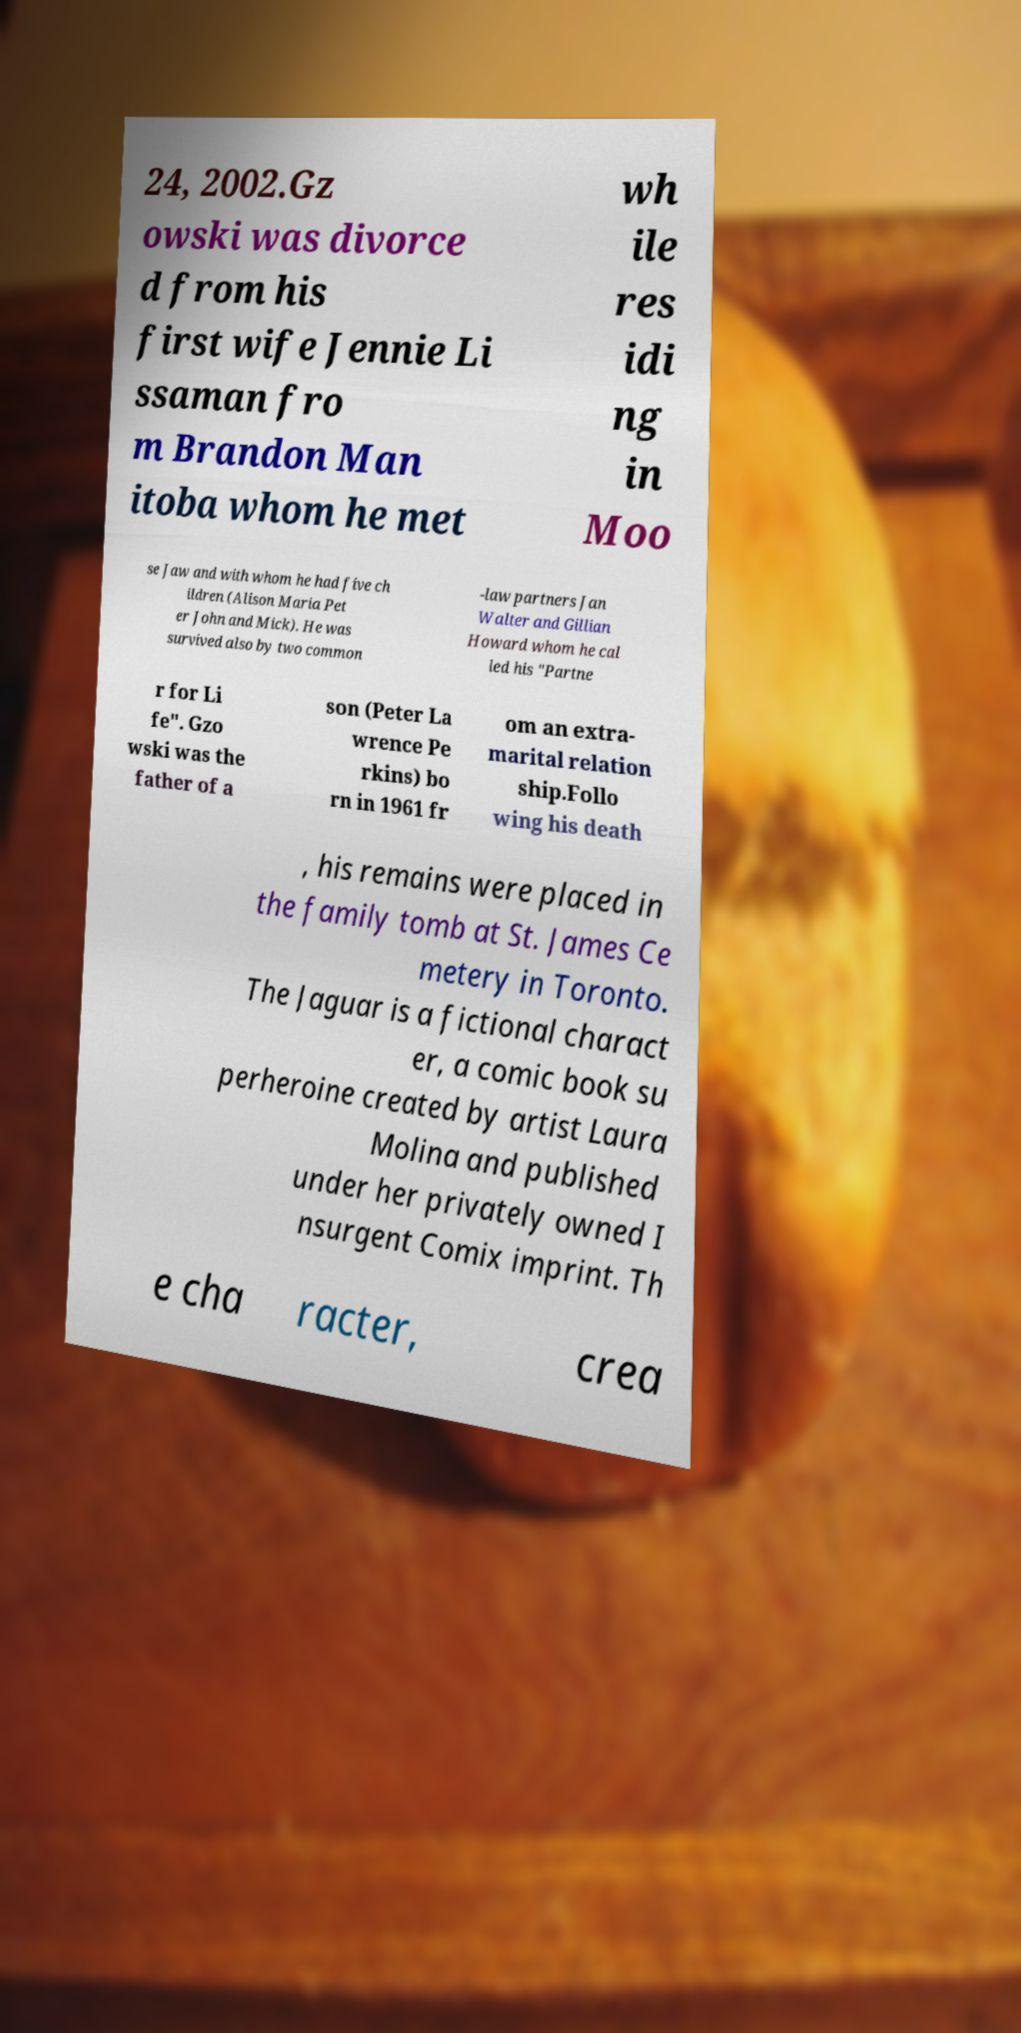What messages or text are displayed in this image? I need them in a readable, typed format. 24, 2002.Gz owski was divorce d from his first wife Jennie Li ssaman fro m Brandon Man itoba whom he met wh ile res idi ng in Moo se Jaw and with whom he had five ch ildren (Alison Maria Pet er John and Mick). He was survived also by two common -law partners Jan Walter and Gillian Howard whom he cal led his "Partne r for Li fe". Gzo wski was the father of a son (Peter La wrence Pe rkins) bo rn in 1961 fr om an extra- marital relation ship.Follo wing his death , his remains were placed in the family tomb at St. James Ce metery in Toronto. The Jaguar is a fictional charact er, a comic book su perheroine created by artist Laura Molina and published under her privately owned I nsurgent Comix imprint. Th e cha racter, crea 